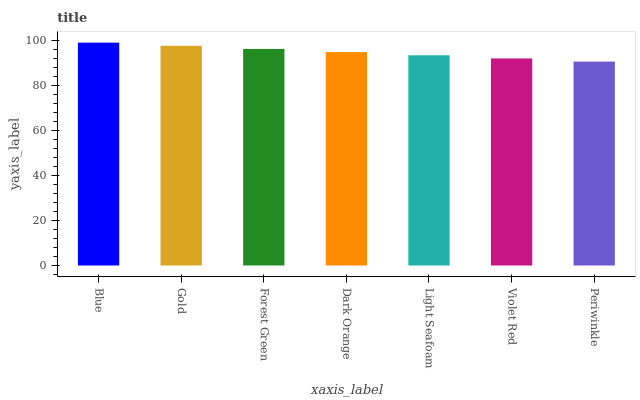Is Periwinkle the minimum?
Answer yes or no. Yes. Is Blue the maximum?
Answer yes or no. Yes. Is Gold the minimum?
Answer yes or no. No. Is Gold the maximum?
Answer yes or no. No. Is Blue greater than Gold?
Answer yes or no. Yes. Is Gold less than Blue?
Answer yes or no. Yes. Is Gold greater than Blue?
Answer yes or no. No. Is Blue less than Gold?
Answer yes or no. No. Is Dark Orange the high median?
Answer yes or no. Yes. Is Dark Orange the low median?
Answer yes or no. Yes. Is Periwinkle the high median?
Answer yes or no. No. Is Forest Green the low median?
Answer yes or no. No. 